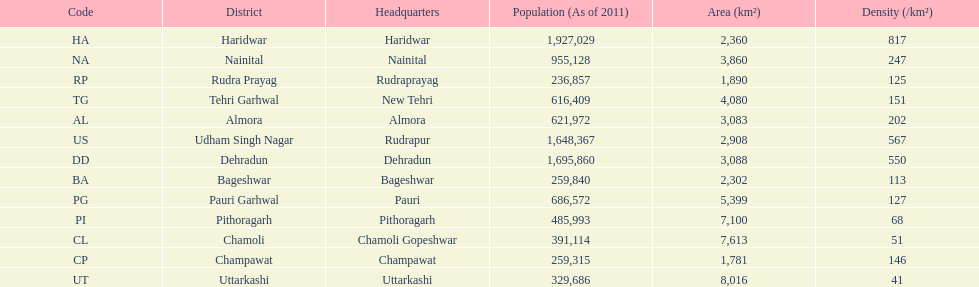Could you parse the entire table as a dict? {'header': ['Code', 'District', 'Headquarters', 'Population (As of 2011)', 'Area (km²)', 'Density (/km²)'], 'rows': [['HA', 'Haridwar', 'Haridwar', '1,927,029', '2,360', '817'], ['NA', 'Nainital', 'Nainital', '955,128', '3,860', '247'], ['RP', 'Rudra Prayag', 'Rudraprayag', '236,857', '1,890', '125'], ['TG', 'Tehri Garhwal', 'New Tehri', '616,409', '4,080', '151'], ['AL', 'Almora', 'Almora', '621,972', '3,083', '202'], ['US', 'Udham Singh Nagar', 'Rudrapur', '1,648,367', '2,908', '567'], ['DD', 'Dehradun', 'Dehradun', '1,695,860', '3,088', '550'], ['BA', 'Bageshwar', 'Bageshwar', '259,840', '2,302', '113'], ['PG', 'Pauri Garhwal', 'Pauri', '686,572', '5,399', '127'], ['PI', 'Pithoragarh', 'Pithoragarh', '485,993', '7,100', '68'], ['CL', 'Chamoli', 'Chamoli Gopeshwar', '391,114', '7,613', '51'], ['CP', 'Champawat', 'Champawat', '259,315', '1,781', '146'], ['UT', 'Uttarkashi', 'Uttarkashi', '329,686', '8,016', '41']]} Which code is above cl BA. 